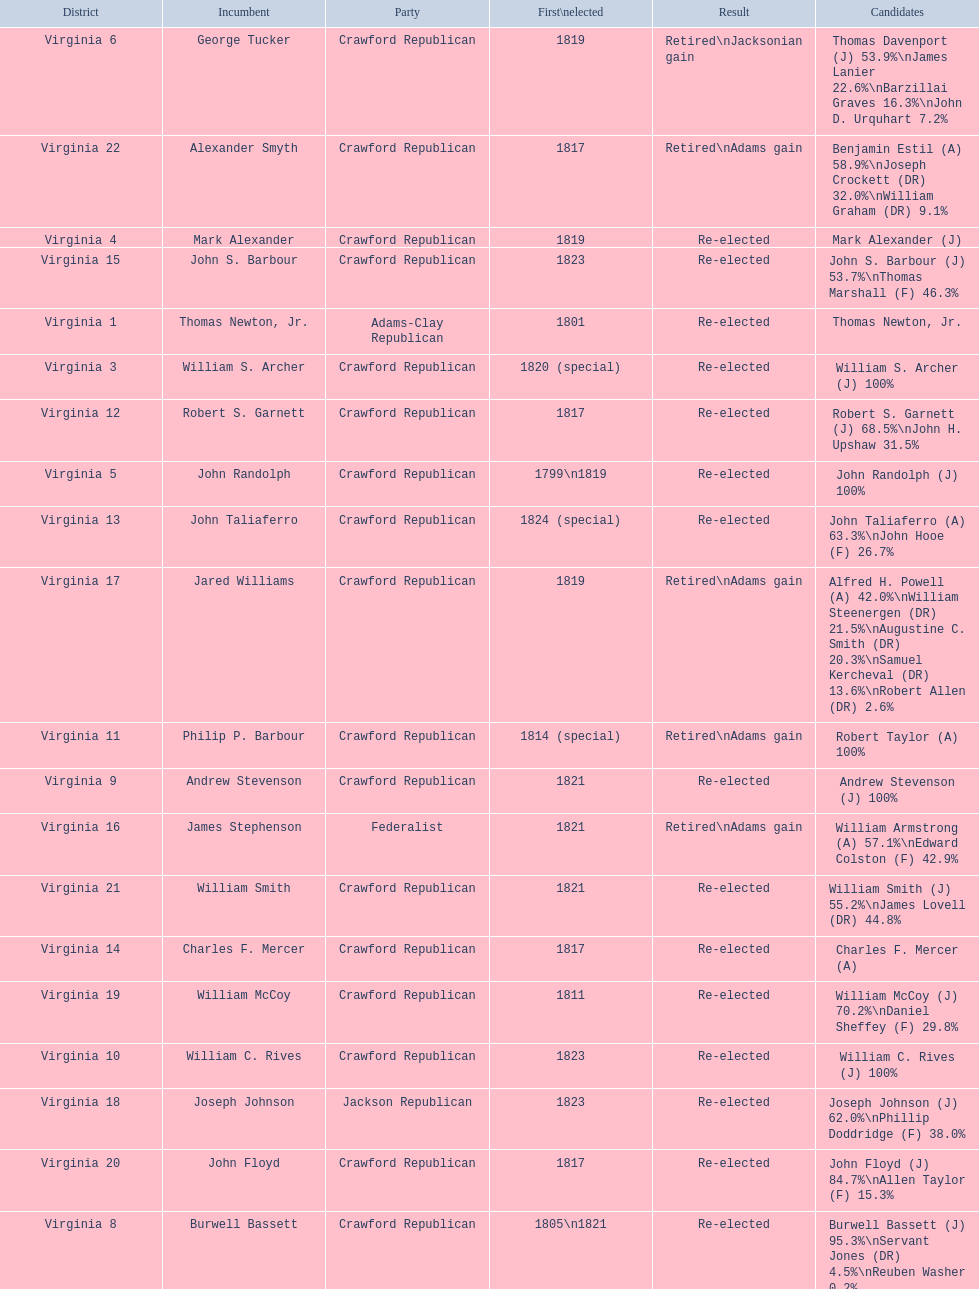Tell me the number of people first elected in 1817. 4. 